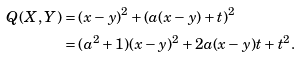<formula> <loc_0><loc_0><loc_500><loc_500>Q ( X , Y ) & = ( x - y ) ^ { 2 } + ( a ( x - y ) + t ) ^ { 2 } \\ & = ( a ^ { 2 } + 1 ) ( x - y ) ^ { 2 } + 2 a ( x - y ) t + t ^ { 2 } .</formula> 